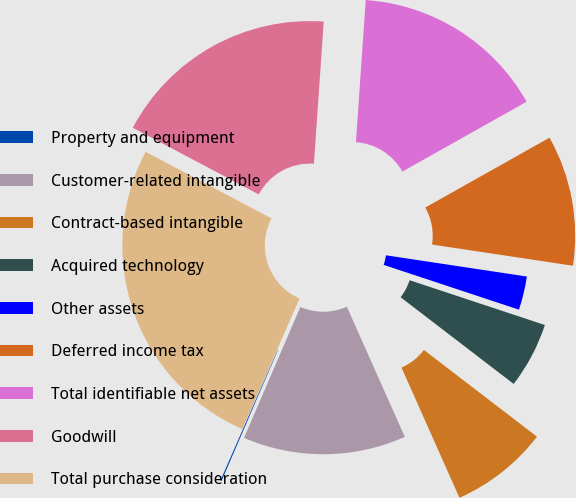Convert chart. <chart><loc_0><loc_0><loc_500><loc_500><pie_chart><fcel>Property and equipment<fcel>Customer-related intangible<fcel>Contract-based intangible<fcel>Acquired technology<fcel>Other assets<fcel>Deferred income tax<fcel>Total identifiable net assets<fcel>Goodwill<fcel>Total purchase consideration<nl><fcel>0.1%<fcel>13.14%<fcel>7.92%<fcel>5.32%<fcel>2.71%<fcel>10.53%<fcel>15.75%<fcel>18.35%<fcel>26.17%<nl></chart> 